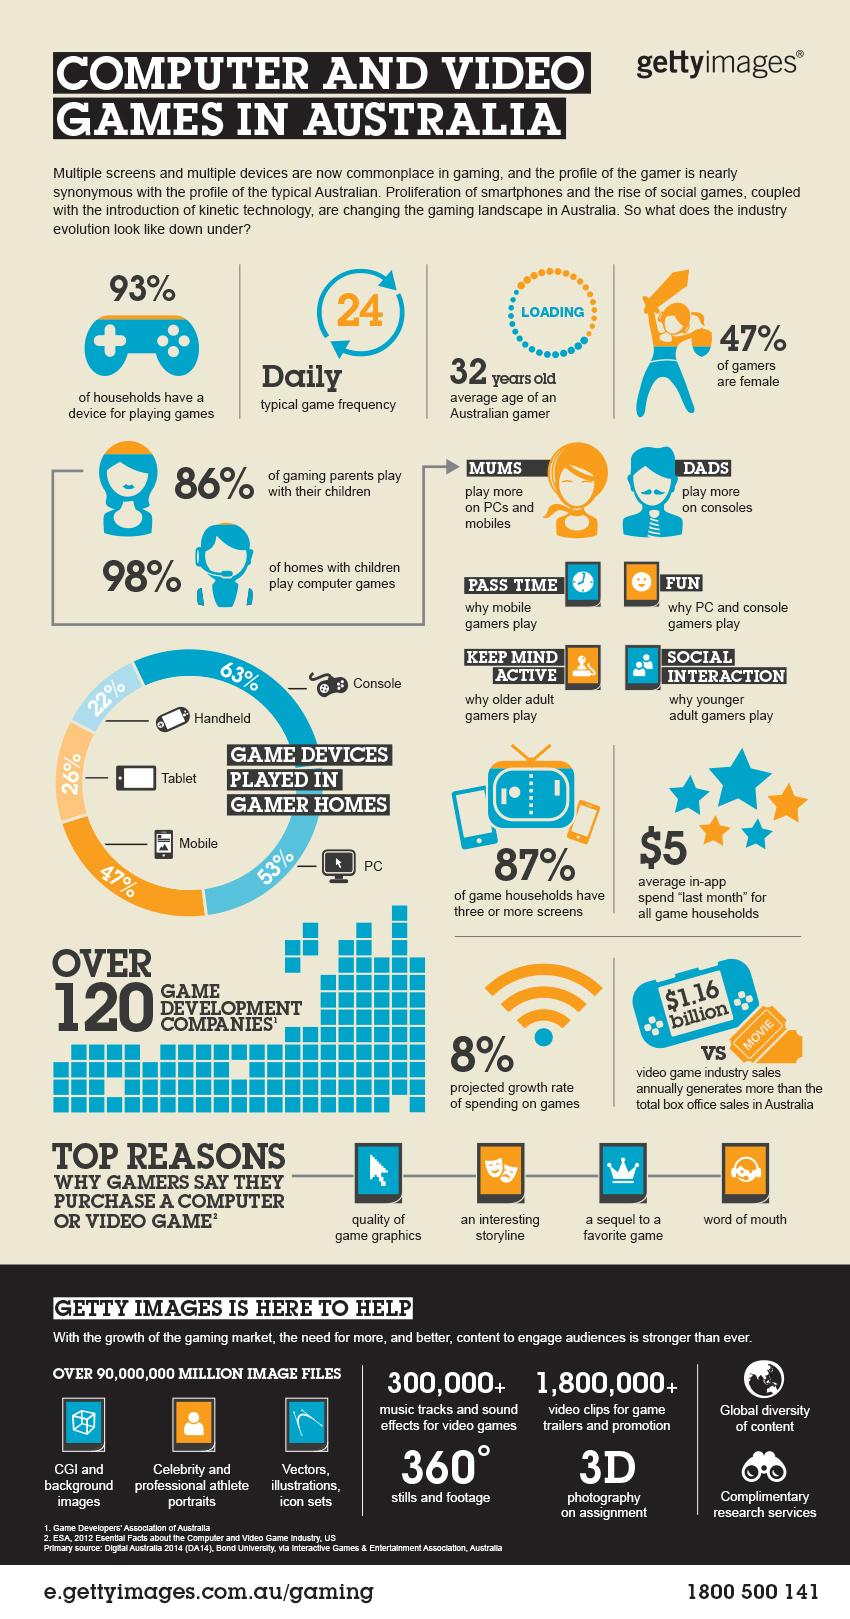Outline some significant characteristics in this image. The projected growth rate of spending on games in Australia is expected to be approximately 8%. According to recent data, only 2% of homes with children in Australia do not play computer games. On a typical day, Australian gamers play games an average of 24 times. The average age of an Australian gamer is 32 years old. The video game industry in Australia generates an annual sales revenue of approximately $1.16 billion. 